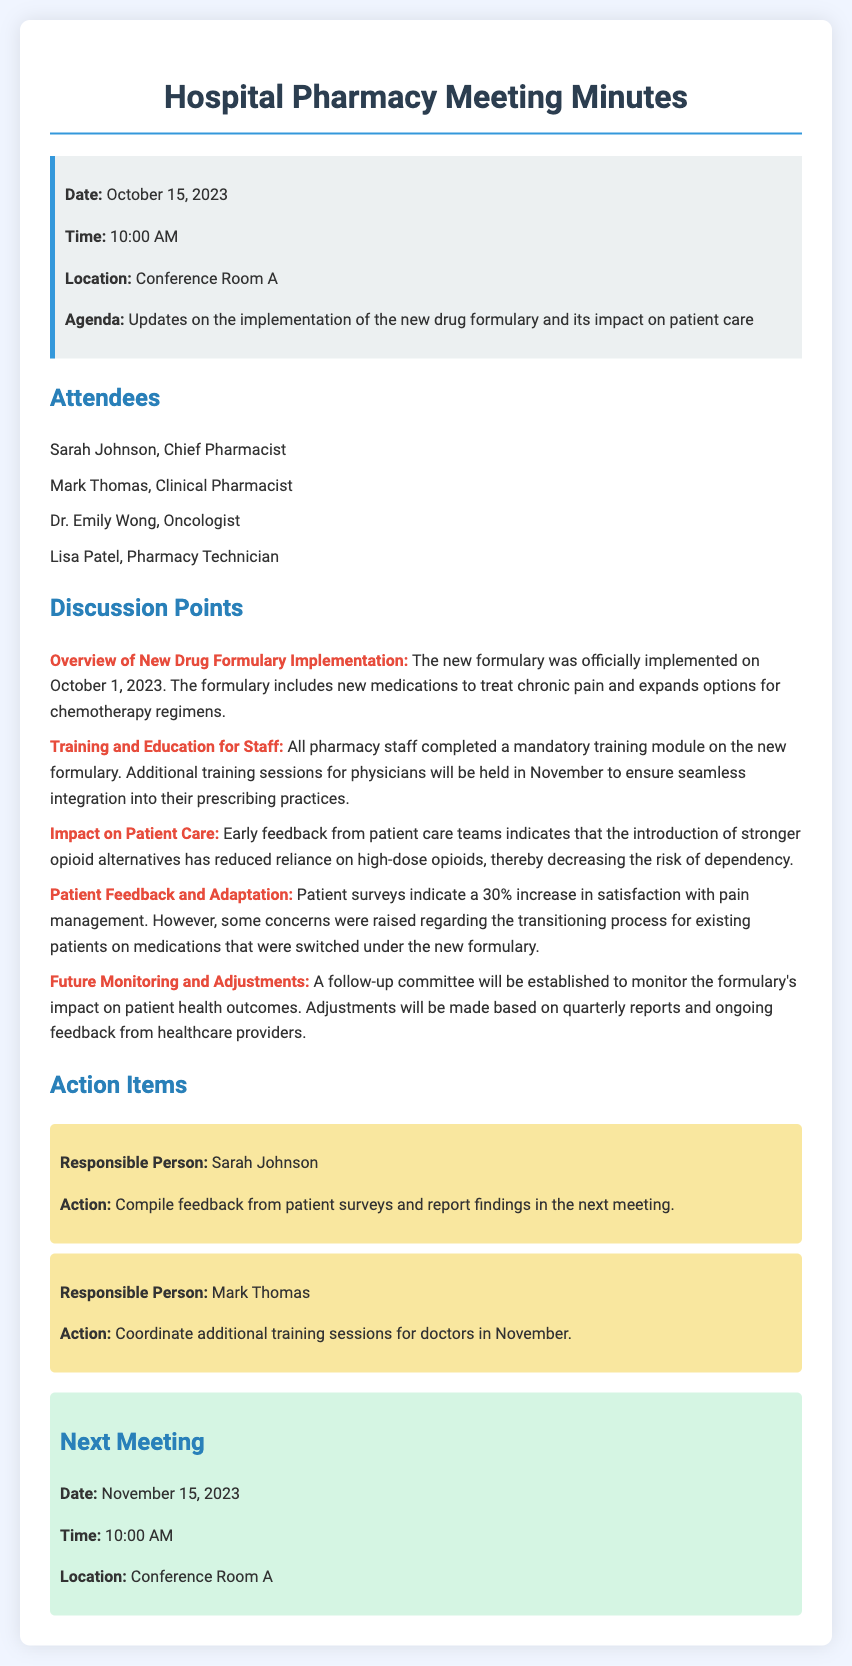what is the date of the meeting? The date of the meeting is specified in the information box at the top of the document.
Answer: October 15, 2023 who is the Chief Pharmacist? The Chief Pharmacist is listed among the attendees at the meeting.
Answer: Sarah Johnson when was the new drug formulary implemented? The implementation date for the new drug formulary is mentioned in the discussion points section.
Answer: October 1, 2023 what percentage increase in patient satisfaction with pain management was reported? The document states the percentage increase based on patient surveys concerning their satisfaction.
Answer: 30% what is one of the actions assigned to Sarah Johnson? The action assigned to Sarah Johnson is detailed in the action items section of the document.
Answer: Compile feedback from patient surveys how will the impact of the new formulary be monitored? The document mentions a follow-up committee to monitor the formulary's impact based on reports and feedback.
Answer: A follow-up committee what is the location of the next meeting? The location for the next meeting is provided towards the end of the document.
Answer: Conference Room A who is responsible for coordinating additional training sessions? The document lists Mark Thomas as responsible in the action items section.
Answer: Mark Thomas 